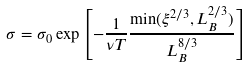Convert formula to latex. <formula><loc_0><loc_0><loc_500><loc_500>\sigma = \sigma _ { 0 } \exp \left [ - \frac { 1 } { \nu T } \frac { \min ( \xi ^ { 2 / 3 } , L _ { B } ^ { 2 / 3 } ) } { L _ { B } ^ { 8 / 3 } } \right ]</formula> 